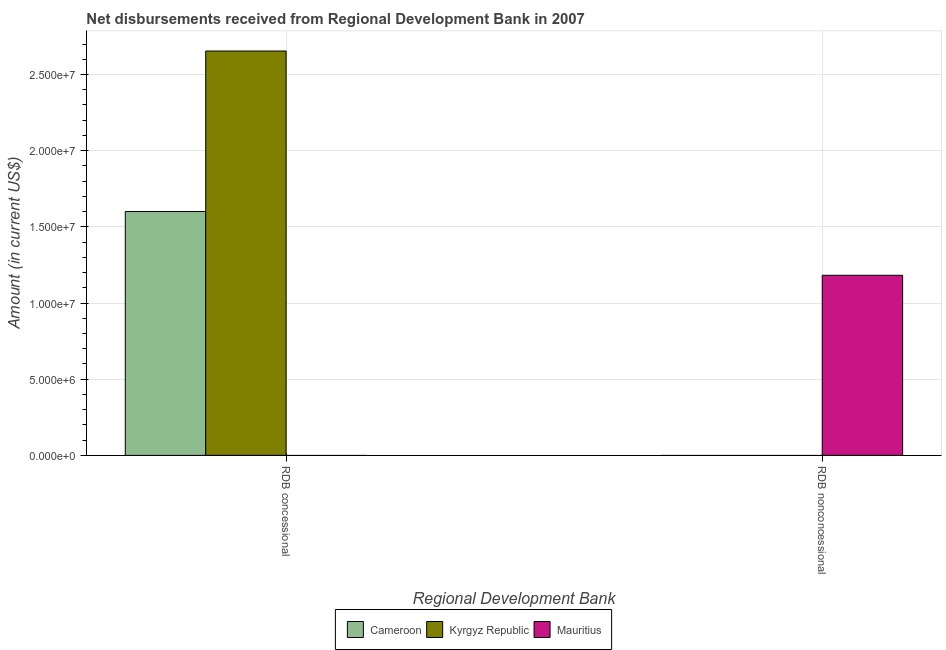How many different coloured bars are there?
Make the answer very short. 3. Are the number of bars per tick equal to the number of legend labels?
Your answer should be compact. No. Are the number of bars on each tick of the X-axis equal?
Your response must be concise. No. What is the label of the 2nd group of bars from the left?
Keep it short and to the point. RDB nonconcessional. What is the net concessional disbursements from rdb in Kyrgyz Republic?
Ensure brevity in your answer.  2.65e+07. Across all countries, what is the maximum net concessional disbursements from rdb?
Keep it short and to the point. 2.65e+07. In which country was the net non concessional disbursements from rdb maximum?
Give a very brief answer. Mauritius. What is the total net non concessional disbursements from rdb in the graph?
Your answer should be compact. 1.18e+07. What is the difference between the net concessional disbursements from rdb in Kyrgyz Republic and that in Cameroon?
Ensure brevity in your answer.  1.05e+07. What is the difference between the net non concessional disbursements from rdb in Mauritius and the net concessional disbursements from rdb in Cameroon?
Provide a short and direct response. -4.19e+06. What is the average net concessional disbursements from rdb per country?
Your response must be concise. 1.42e+07. In how many countries, is the net concessional disbursements from rdb greater than 26000000 US$?
Give a very brief answer. 1. What is the ratio of the net concessional disbursements from rdb in Cameroon to that in Kyrgyz Republic?
Ensure brevity in your answer.  0.6. How many bars are there?
Offer a terse response. 3. Are the values on the major ticks of Y-axis written in scientific E-notation?
Ensure brevity in your answer.  Yes. Does the graph contain any zero values?
Your answer should be compact. Yes. Does the graph contain grids?
Keep it short and to the point. Yes. How many legend labels are there?
Give a very brief answer. 3. How are the legend labels stacked?
Give a very brief answer. Horizontal. What is the title of the graph?
Your answer should be very brief. Net disbursements received from Regional Development Bank in 2007. What is the label or title of the X-axis?
Give a very brief answer. Regional Development Bank. What is the Amount (in current US$) of Cameroon in RDB concessional?
Provide a succinct answer. 1.60e+07. What is the Amount (in current US$) of Kyrgyz Republic in RDB concessional?
Ensure brevity in your answer.  2.65e+07. What is the Amount (in current US$) in Kyrgyz Republic in RDB nonconcessional?
Keep it short and to the point. 0. What is the Amount (in current US$) of Mauritius in RDB nonconcessional?
Your answer should be very brief. 1.18e+07. Across all Regional Development Bank, what is the maximum Amount (in current US$) of Cameroon?
Offer a very short reply. 1.60e+07. Across all Regional Development Bank, what is the maximum Amount (in current US$) in Kyrgyz Republic?
Keep it short and to the point. 2.65e+07. Across all Regional Development Bank, what is the maximum Amount (in current US$) in Mauritius?
Make the answer very short. 1.18e+07. Across all Regional Development Bank, what is the minimum Amount (in current US$) of Mauritius?
Provide a short and direct response. 0. What is the total Amount (in current US$) in Cameroon in the graph?
Keep it short and to the point. 1.60e+07. What is the total Amount (in current US$) in Kyrgyz Republic in the graph?
Your answer should be very brief. 2.65e+07. What is the total Amount (in current US$) of Mauritius in the graph?
Keep it short and to the point. 1.18e+07. What is the difference between the Amount (in current US$) of Cameroon in RDB concessional and the Amount (in current US$) of Mauritius in RDB nonconcessional?
Your response must be concise. 4.19e+06. What is the difference between the Amount (in current US$) of Kyrgyz Republic in RDB concessional and the Amount (in current US$) of Mauritius in RDB nonconcessional?
Your answer should be compact. 1.47e+07. What is the average Amount (in current US$) in Cameroon per Regional Development Bank?
Provide a short and direct response. 8.00e+06. What is the average Amount (in current US$) of Kyrgyz Republic per Regional Development Bank?
Your response must be concise. 1.33e+07. What is the average Amount (in current US$) in Mauritius per Regional Development Bank?
Your answer should be very brief. 5.91e+06. What is the difference between the Amount (in current US$) in Cameroon and Amount (in current US$) in Kyrgyz Republic in RDB concessional?
Your answer should be very brief. -1.05e+07. What is the difference between the highest and the lowest Amount (in current US$) of Cameroon?
Your answer should be very brief. 1.60e+07. What is the difference between the highest and the lowest Amount (in current US$) in Kyrgyz Republic?
Keep it short and to the point. 2.65e+07. What is the difference between the highest and the lowest Amount (in current US$) of Mauritius?
Keep it short and to the point. 1.18e+07. 